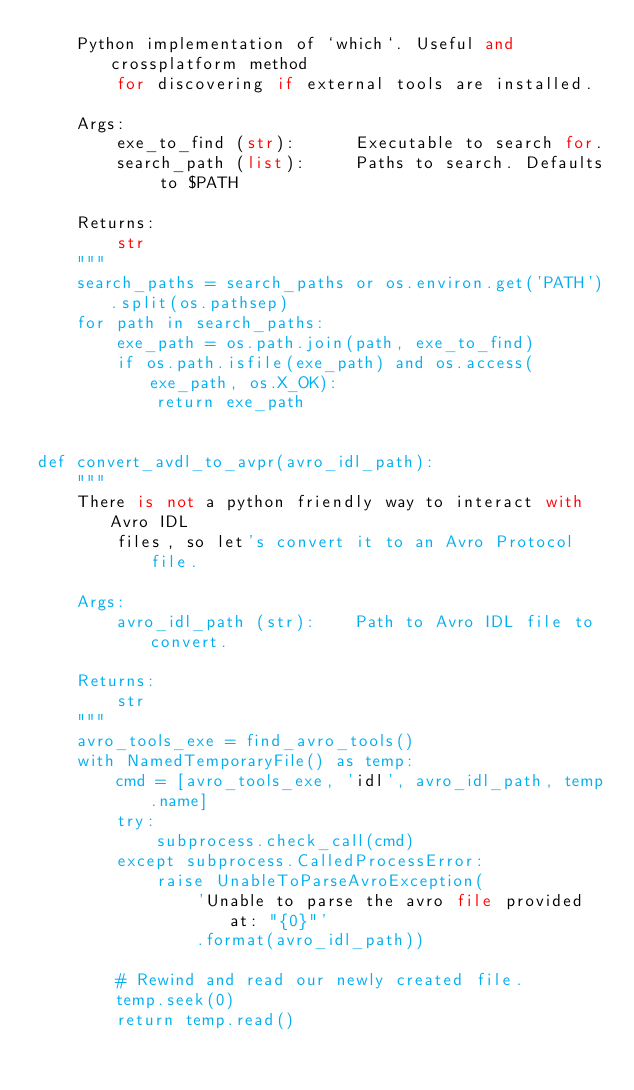<code> <loc_0><loc_0><loc_500><loc_500><_Python_>    Python implementation of `which`. Useful and crossplatform method
        for discovering if external tools are installed.

    Args:
        exe_to_find (str):      Executable to search for.
        search_path (list):     Paths to search. Defaults to $PATH

    Returns:
        str
    """
    search_paths = search_paths or os.environ.get('PATH').split(os.pathsep)
    for path in search_paths:
        exe_path = os.path.join(path, exe_to_find)
        if os.path.isfile(exe_path) and os.access(exe_path, os.X_OK):
            return exe_path


def convert_avdl_to_avpr(avro_idl_path):
    """
    There is not a python friendly way to interact with Avro IDL
        files, so let's convert it to an Avro Protocol file.

    Args:
        avro_idl_path (str):    Path to Avro IDL file to convert.

    Returns:
        str
    """
    avro_tools_exe = find_avro_tools()
    with NamedTemporaryFile() as temp:
        cmd = [avro_tools_exe, 'idl', avro_idl_path, temp.name]
        try:
            subprocess.check_call(cmd)
        except subprocess.CalledProcessError:
            raise UnableToParseAvroException(
                'Unable to parse the avro file provided at: "{0}"'
                .format(avro_idl_path))

        # Rewind and read our newly created file.
        temp.seek(0)
        return temp.read()
</code> 